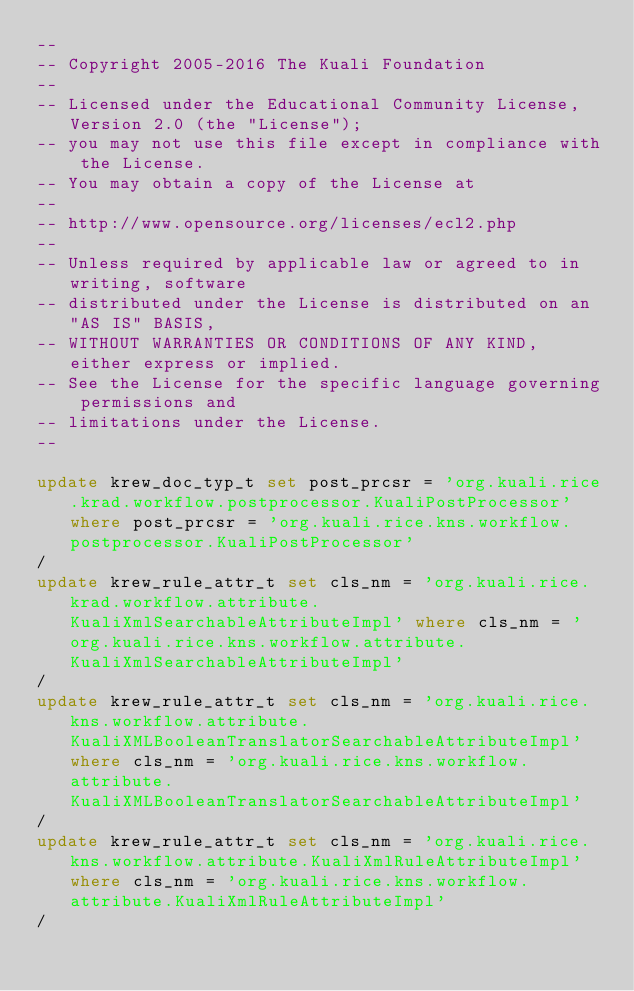Convert code to text. <code><loc_0><loc_0><loc_500><loc_500><_SQL_>--
-- Copyright 2005-2016 The Kuali Foundation
--
-- Licensed under the Educational Community License, Version 2.0 (the "License");
-- you may not use this file except in compliance with the License.
-- You may obtain a copy of the License at
--
-- http://www.opensource.org/licenses/ecl2.php
--
-- Unless required by applicable law or agreed to in writing, software
-- distributed under the License is distributed on an "AS IS" BASIS,
-- WITHOUT WARRANTIES OR CONDITIONS OF ANY KIND, either express or implied.
-- See the License for the specific language governing permissions and
-- limitations under the License.
--

update krew_doc_typ_t set post_prcsr = 'org.kuali.rice.krad.workflow.postprocessor.KualiPostProcessor' where post_prcsr = 'org.kuali.rice.kns.workflow.postprocessor.KualiPostProcessor'
/
update krew_rule_attr_t set cls_nm = 'org.kuali.rice.krad.workflow.attribute.KualiXmlSearchableAttributeImpl' where cls_nm = 'org.kuali.rice.kns.workflow.attribute.KualiXmlSearchableAttributeImpl'
/
update krew_rule_attr_t set cls_nm = 'org.kuali.rice.kns.workflow.attribute.KualiXMLBooleanTranslatorSearchableAttributeImpl' where cls_nm = 'org.kuali.rice.kns.workflow.attribute.KualiXMLBooleanTranslatorSearchableAttributeImpl'
/
update krew_rule_attr_t set cls_nm = 'org.kuali.rice.kns.workflow.attribute.KualiXmlRuleAttributeImpl' where cls_nm = 'org.kuali.rice.kns.workflow.attribute.KualiXmlRuleAttributeImpl'
/</code> 